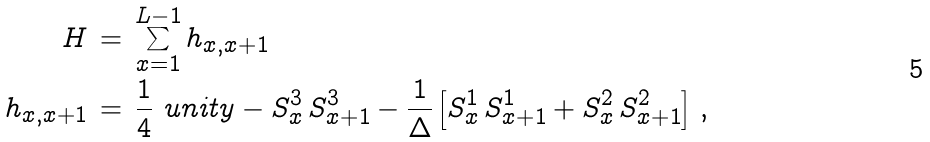<formula> <loc_0><loc_0><loc_500><loc_500>H \, & = \, \sum _ { x = 1 } ^ { L - 1 } h _ { x , x + 1 } \\ h _ { x , x + 1 } \, & = \, \frac { 1 } { 4 } \ u n i t y - S _ { x } ^ { 3 } \, S _ { x + 1 } ^ { 3 } - \frac { 1 } { \Delta } \left [ S _ { x } ^ { 1 } \, S _ { x + 1 } ^ { 1 } + S _ { x } ^ { 2 } \, S _ { x + 1 } ^ { 2 } \right ] \, ,</formula> 